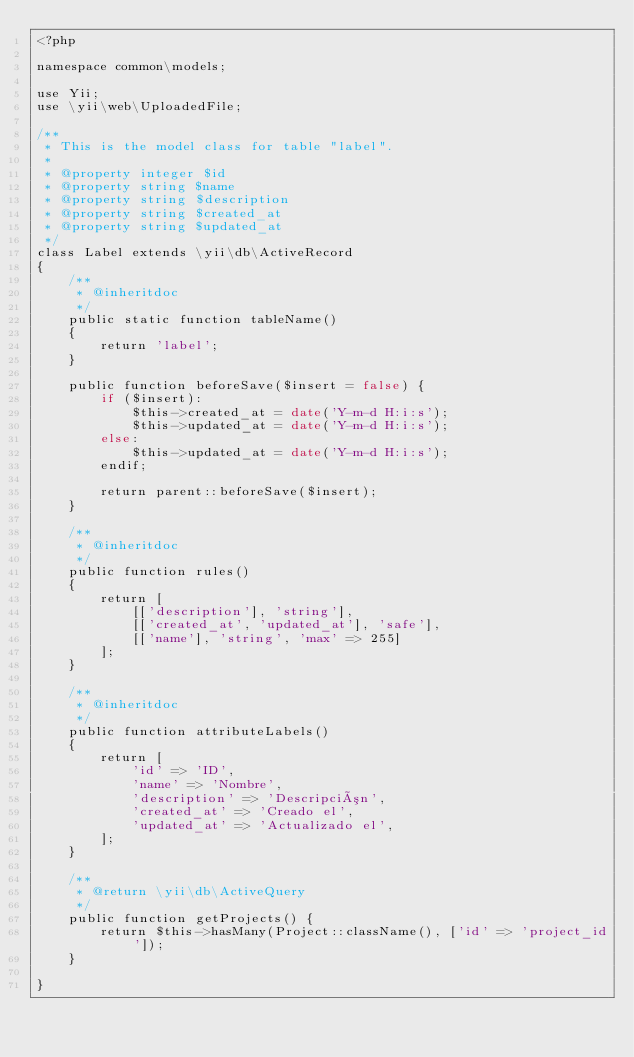Convert code to text. <code><loc_0><loc_0><loc_500><loc_500><_PHP_><?php

namespace common\models;

use Yii;
use \yii\web\UploadedFile;

/**
 * This is the model class for table "label".
 *
 * @property integer $id
 * @property string $name
 * @property string $description
 * @property string $created_at
 * @property string $updated_at
 */
class Label extends \yii\db\ActiveRecord
{
    /**
     * @inheritdoc
     */
    public static function tableName()
    {
        return 'label';
    }

    public function beforeSave($insert = false) {
        if ($insert):
            $this->created_at = date('Y-m-d H:i:s');
            $this->updated_at = date('Y-m-d H:i:s');
        else:
            $this->updated_at = date('Y-m-d H:i:s');
        endif;

        return parent::beforeSave($insert);
    }

    /**
     * @inheritdoc
     */
    public function rules()
    {
        return [
            [['description'], 'string'],
            [['created_at', 'updated_at'], 'safe'],
            [['name'], 'string', 'max' => 255]
        ];
    }

    /**
     * @inheritdoc
     */
    public function attributeLabels()
    {
        return [
            'id' => 'ID',
            'name' => 'Nombre',
            'description' => 'Descripción',
            'created_at' => 'Creado el',
            'updated_at' => 'Actualizado el',
        ];
    }

    /**
     * @return \yii\db\ActiveQuery
     */
    public function getProjects() {
        return $this->hasMany(Project::className(), ['id' => 'project_id']);
    }

}
</code> 